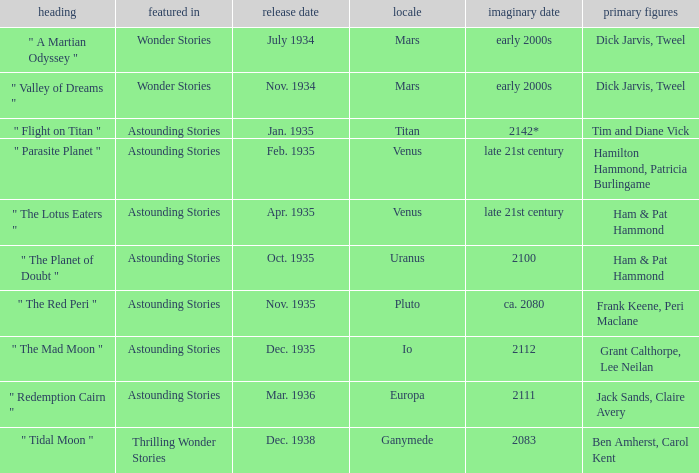Name what was published in july 1934 with a setting of mars Wonder Stories. 